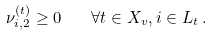Convert formula to latex. <formula><loc_0><loc_0><loc_500><loc_500>\nu ^ { ( t ) } _ { i , 2 } \geq 0 \quad \forall t \in X _ { v } , i \in L _ { t } \, .</formula> 